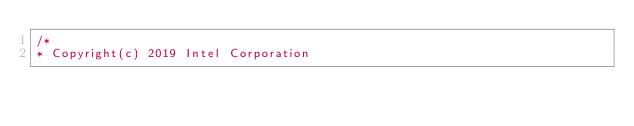<code> <loc_0><loc_0><loc_500><loc_500><_C_>/*
* Copyright(c) 2019 Intel Corporation</code> 